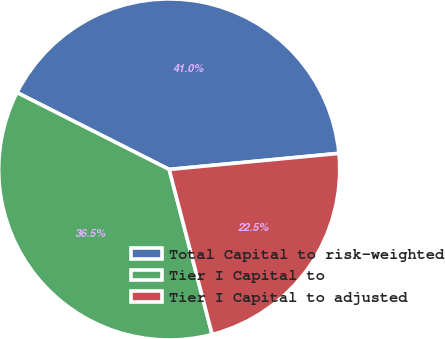<chart> <loc_0><loc_0><loc_500><loc_500><pie_chart><fcel>Total Capital to risk-weighted<fcel>Tier I Capital to<fcel>Tier I Capital to adjusted<nl><fcel>41.05%<fcel>36.5%<fcel>22.45%<nl></chart> 